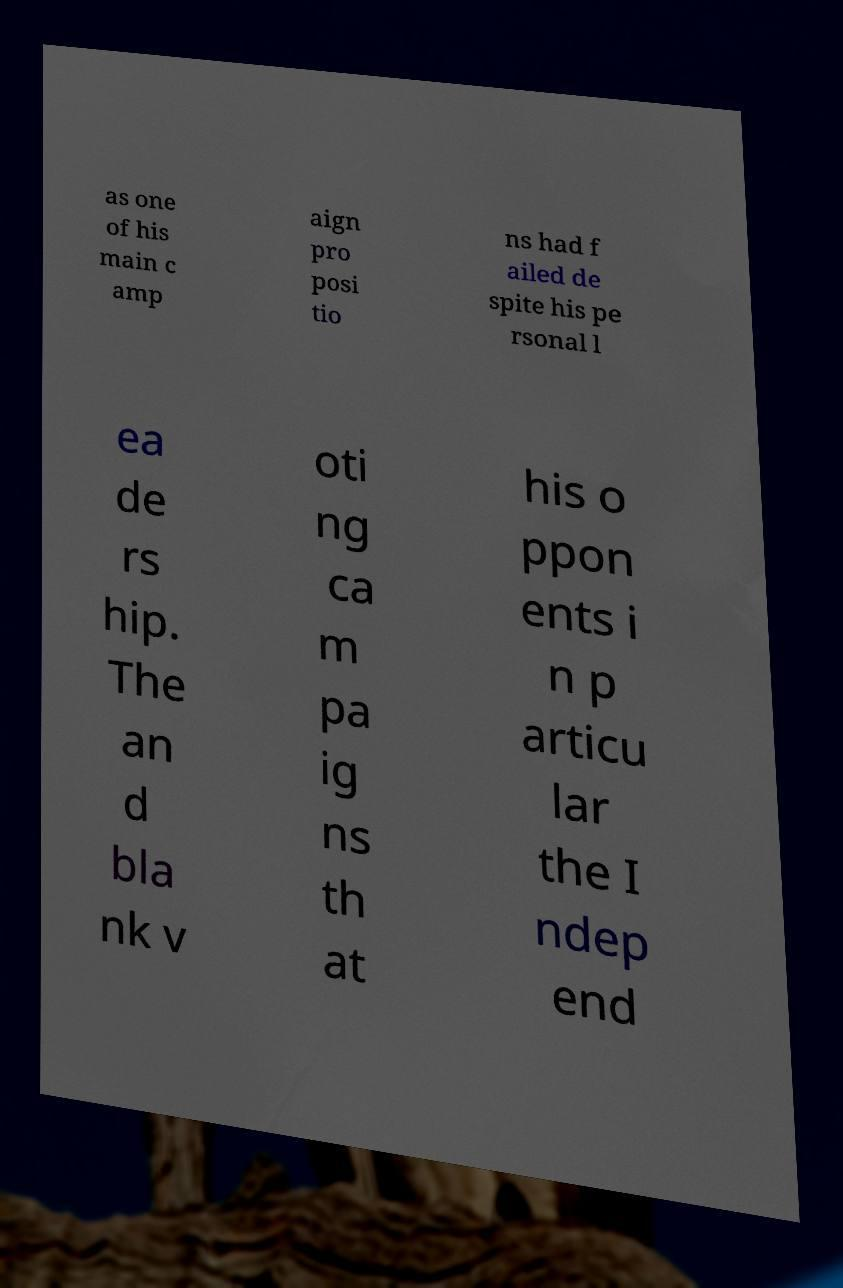I need the written content from this picture converted into text. Can you do that? as one of his main c amp aign pro posi tio ns had f ailed de spite his pe rsonal l ea de rs hip. The an d bla nk v oti ng ca m pa ig ns th at his o ppon ents i n p articu lar the I ndep end 